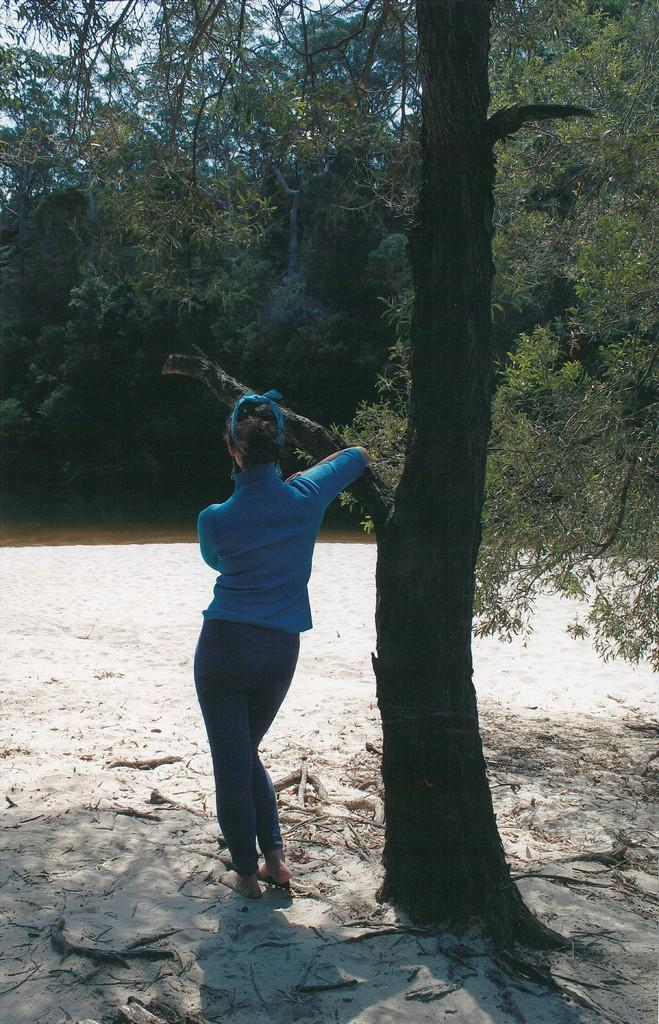Who is present in the image? There is a woman in the image. What is the woman wearing? The woman is wearing a blue T-shirt and blue jeans. Where is the woman standing in the image? The woman is standing beside a tree. What type of terrain is visible at the bottom of the image? There is sand and twigs visible at the bottom of the image. What can be seen in the background of the image? There are trees in the background of the image. What type of faucet can be seen in the image? There is no faucet present in the image. Who is the woman in the image having a conversation with? The provided facts do not mention any other person in the image, so it is not possible to determine who the woman is having a conversation with. 